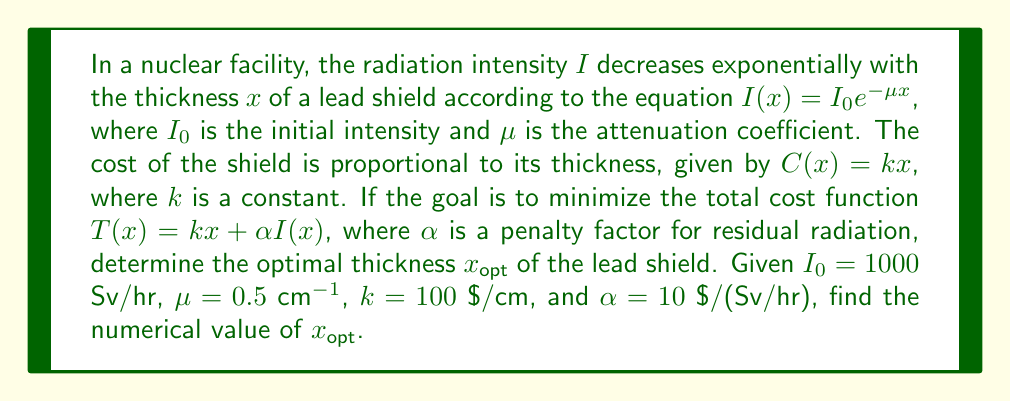Teach me how to tackle this problem. To solve this optimization problem, we'll use calculus techniques:

1) First, let's write out the total cost function:

   $T(x) = kx + \alpha I(x) = kx + \alpha I_0 e^{-\mu x}$

2) To find the minimum, we need to differentiate $T(x)$ with respect to $x$ and set it equal to zero:

   $$\frac{dT}{dx} = k - \alpha I_0 \mu e^{-\mu x} = 0$$

3) Solving this equation:

   $k = \alpha I_0 \mu e^{-\mu x}$

   $e^{-\mu x} = \frac{k}{\alpha I_0 \mu}$

   $-\mu x = \ln(\frac{k}{\alpha I_0 \mu})$

   $x_{opt} = -\frac{1}{\mu} \ln(\frac{k}{\alpha I_0 \mu})$

4) Now, let's substitute the given values:

   $I_0 = 1000$ Sv/hr
   $\mu = 0.5$ cm$^{-1}$
   $k = 100$ $/cm
   $\alpha = 10$ $/(Sv/hr)

5) Plugging these into our equation:

   $x_{opt} = -\frac{1}{0.5} \ln(\frac{100}{10 * 1000 * 0.5})$

6) Simplifying:

   $x_{opt} = -2 \ln(0.02) = -2 * (-3.912) = 7.824$ cm

Therefore, the optimal thickness of the lead shield is approximately 7.824 cm.
Answer: $x_{opt} \approx 7.824$ cm 